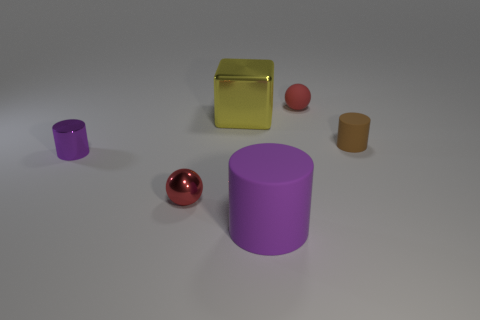Add 2 spheres. How many objects exist? 8 Subtract all small cylinders. How many cylinders are left? 1 Subtract all balls. How many objects are left? 4 Add 1 blue metallic cubes. How many blue metallic cubes exist? 1 Subtract 0 brown spheres. How many objects are left? 6 Subtract all purple objects. Subtract all red things. How many objects are left? 2 Add 1 purple objects. How many purple objects are left? 3 